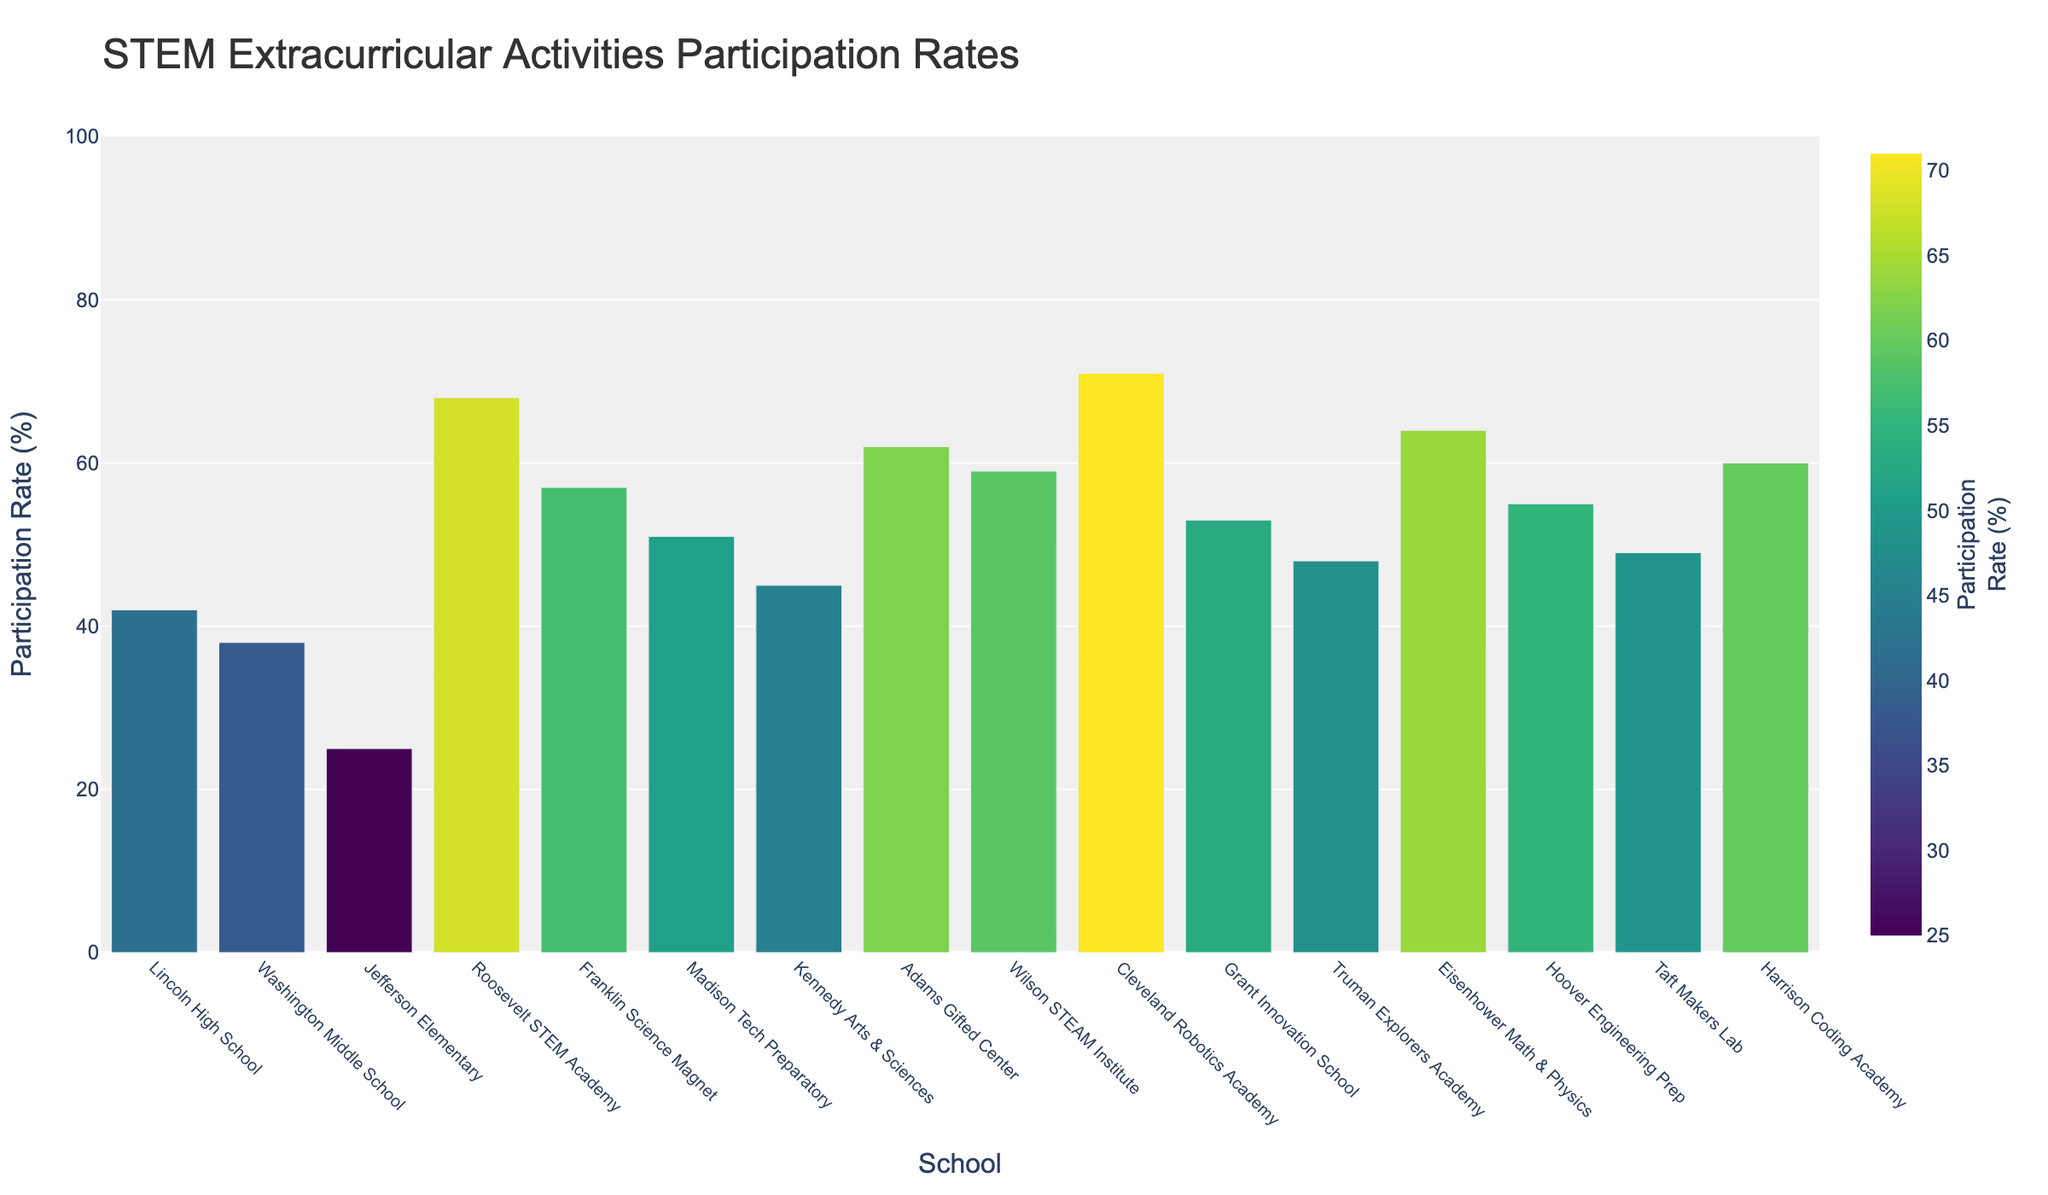Which school has the highest participation rate in STEM extracurricular activities? The bar representing Cleveland Robotics Academy is the tallest among all, indicating the highest participation rate.
Answer: Cleveland Robotics Academy What is the average participation rate across all schools? To calculate the average, sum the participation rates of all schools and divide by the number of schools. (42 + 38 + 25 + 68 + 57 + 51 + 45 + 62 + 59 + 71 + 53 + 48 + 64 + 55 + 49 + 60) / 16 = 847 / 16 = 52.9375
Answer: 52.94 Which school has a higher participation rate, Adams Gifted Center or Harrison Coding Academy? Compare the heights of the bars for Adams Gifted Center and Harrison Coding Academy. Adams Gifted Center has a participation rate of 62%, which is higher than Harrison Coding Academy's 60%.
Answer: Adams Gifted Center What is the difference in participation rates between Jefferson Elementary and Roosevelt STEM Academy? Subtract the participation rate of Jefferson Elementary from that of Roosevelt STEM Academy. 68% - 25% = 43%
Answer: 43% Are there any schools with a participation rate lower than 30%? Check the bars with participation rates below 30%. Jefferson Elementary has a participation rate of 25%.
Answer: Yes, Jefferson Elementary What is the median participation rate among these schools? Arrange the participation rates in ascending order and find the middle value(s). In this case, 25, 38, 42, 45, 48, 49, 51, 53, 55, 57, 59, 60, 62, 64, 68, 71. The median is the average of the 8th and 9th values: (53 + 55) / 2 = 54
Answer: 54 Which schools have participation rates above 60%? Identify the bars representing participation rates above 60%. Schools include Roosevelt STEM Academy (68%), Adams Gifted Center (62%), Cleveland Robotics Academy (71%), and Eisenhower Math & Physics (64%).
Answer: Roosevelt STEM Academy, Adams Gifted Center, Cleveland Robotics Academy, Eisenhower Math & Physics What is the total participation rate for Washington Middle School, Lincoln High School, and Kennedy Arts & Sciences? Add their participation rates: 38 + 42 + 45 = 125
Answer: 125 How much higher is Cleveland Robotics Academy's participation rate compared to the average participation rate? First, find the average participation rate (52.94%), then subtract it from Cleveland Robotics Academy's rate (71%): 71 - 52.94 = 18.06
Answer: 18.06 Which school has the third highest participation rate, and what is that rate? Order the participation rates in descending order and identify the third highest: Cleveland Robotics Academy (71%), Roosevelt STEM Academy (68%), Eisenhower Math & Physics (64%). The third highest is Eisenhower Math & Physics with 64%.
Answer: Eisenhower Math & Physics, 64% 